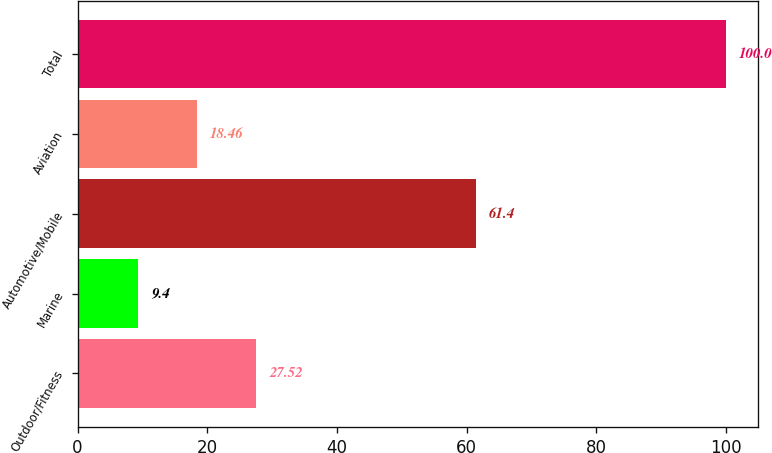Convert chart. <chart><loc_0><loc_0><loc_500><loc_500><bar_chart><fcel>Outdoor/Fitness<fcel>Marine<fcel>Automotive/Mobile<fcel>Aviation<fcel>Total<nl><fcel>27.52<fcel>9.4<fcel>61.4<fcel>18.46<fcel>100<nl></chart> 